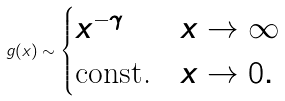Convert formula to latex. <formula><loc_0><loc_0><loc_500><loc_500>g ( x ) \sim \begin{cases} x ^ { - \gamma } & x \to \infty \\ \text {const.} & x \to 0 . \end{cases}</formula> 